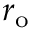<formula> <loc_0><loc_0><loc_500><loc_500>r _ { o }</formula> 